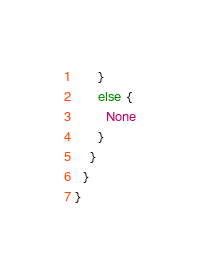<code> <loc_0><loc_0><loc_500><loc_500><_Scala_>      }
      else {
        None
      }
    }
  }
}
</code> 